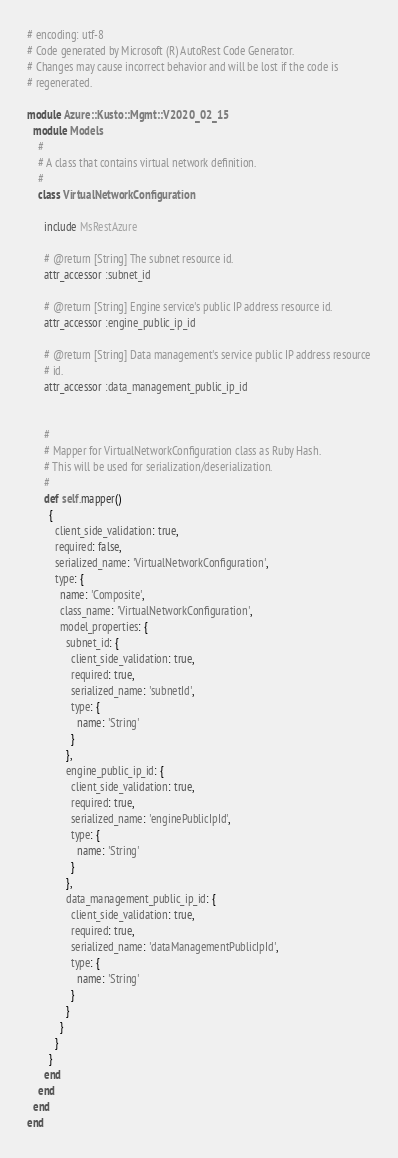Convert code to text. <code><loc_0><loc_0><loc_500><loc_500><_Ruby_># encoding: utf-8
# Code generated by Microsoft (R) AutoRest Code Generator.
# Changes may cause incorrect behavior and will be lost if the code is
# regenerated.

module Azure::Kusto::Mgmt::V2020_02_15
  module Models
    #
    # A class that contains virtual network definition.
    #
    class VirtualNetworkConfiguration

      include MsRestAzure

      # @return [String] The subnet resource id.
      attr_accessor :subnet_id

      # @return [String] Engine service's public IP address resource id.
      attr_accessor :engine_public_ip_id

      # @return [String] Data management's service public IP address resource
      # id.
      attr_accessor :data_management_public_ip_id


      #
      # Mapper for VirtualNetworkConfiguration class as Ruby Hash.
      # This will be used for serialization/deserialization.
      #
      def self.mapper()
        {
          client_side_validation: true,
          required: false,
          serialized_name: 'VirtualNetworkConfiguration',
          type: {
            name: 'Composite',
            class_name: 'VirtualNetworkConfiguration',
            model_properties: {
              subnet_id: {
                client_side_validation: true,
                required: true,
                serialized_name: 'subnetId',
                type: {
                  name: 'String'
                }
              },
              engine_public_ip_id: {
                client_side_validation: true,
                required: true,
                serialized_name: 'enginePublicIpId',
                type: {
                  name: 'String'
                }
              },
              data_management_public_ip_id: {
                client_side_validation: true,
                required: true,
                serialized_name: 'dataManagementPublicIpId',
                type: {
                  name: 'String'
                }
              }
            }
          }
        }
      end
    end
  end
end
</code> 